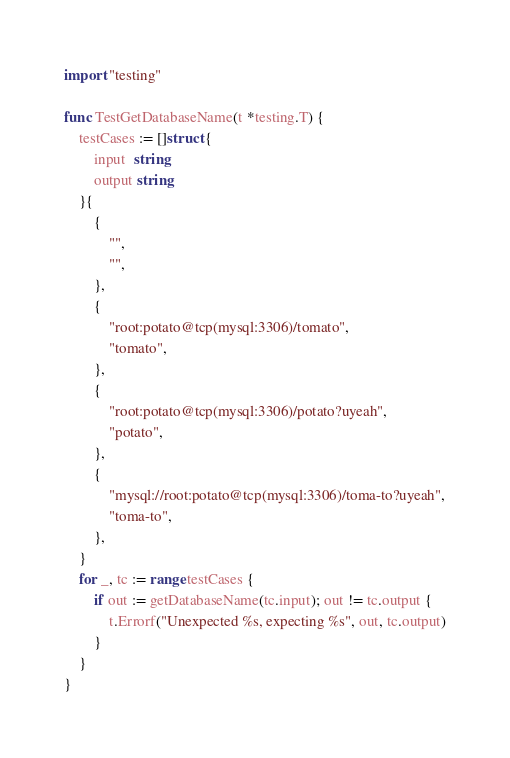Convert code to text. <code><loc_0><loc_0><loc_500><loc_500><_Go_>import "testing"

func TestGetDatabaseName(t *testing.T) {
	testCases := []struct {
		input  string
		output string
	}{
		{
			"",
			"",
		},
		{
			"root:potato@tcp(mysql:3306)/tomato",
			"tomato",
		},
		{
			"root:potato@tcp(mysql:3306)/potato?uyeah",
			"potato",
		},
		{
			"mysql://root:potato@tcp(mysql:3306)/toma-to?uyeah",
			"toma-to",
		},
	}
	for _, tc := range testCases {
		if out := getDatabaseName(tc.input); out != tc.output {
			t.Errorf("Unexpected %s, expecting %s", out, tc.output)
		}
	}
}
</code> 